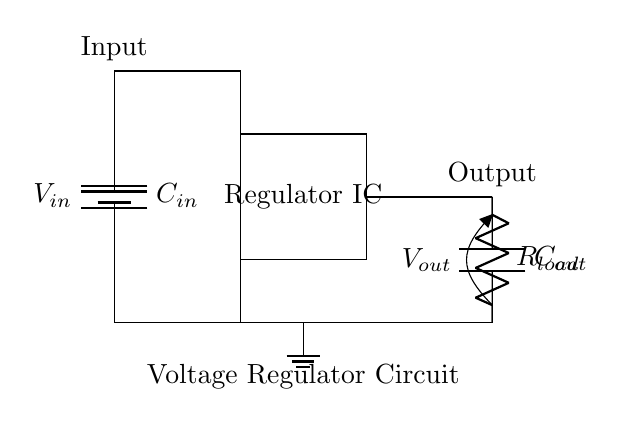What is the input component of the circuit? The input component, as marked in the diagram, is a battery, which serves as the voltage supply to the rest of the circuit, providing the input voltage.
Answer: Battery What is the purpose of the capacitor labeled C out? The capacitor labeled C out is used to stabilize the output voltage by filtering any high-frequency noise or fluctuations that might be present in the output from the voltage regulator.
Answer: Stabilization How is the load connected in this circuit? The load resistor is connected in parallel to the output capacitor and is part of the output side of the circuit, receiving the regulated output voltage directly.
Answer: Parallel connection What indicates the function of the rectangular component? The rectangular component represents a voltage regulator integrated circuit (IC), signifying that it regulates the output voltage to a specific level from the input voltage provided.
Answer: Voltage regulator IC What is the output voltage referred to in this circuit? The output voltage is indicated as V out, displaying the voltage level that is provided to the load resistor after regulation, ensuring stability and performance.
Answer: V out What role does the capacitor labeled C in play in the circuit? The capacitor labeled C in serves to smooth the input voltage by reducing rapid voltage fluctuations, enhancing the performance stability of the voltage regulator IC.
Answer: Smoothing input How does this circuit ensure voltage regulation? The circuit uses a voltage regulator IC, which maintains a consistent output voltage regardless of variations in input voltage or load current, thus ensuring reliable operation in portable devices.
Answer: Voltage regulation 